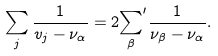<formula> <loc_0><loc_0><loc_500><loc_500>\sum _ { j } \frac { 1 } { v _ { j } - \nu _ { \alpha } } = 2 { \sum _ { \beta } } ^ { \prime } \frac { 1 } { \nu _ { \beta } - \nu _ { \alpha } } .</formula> 